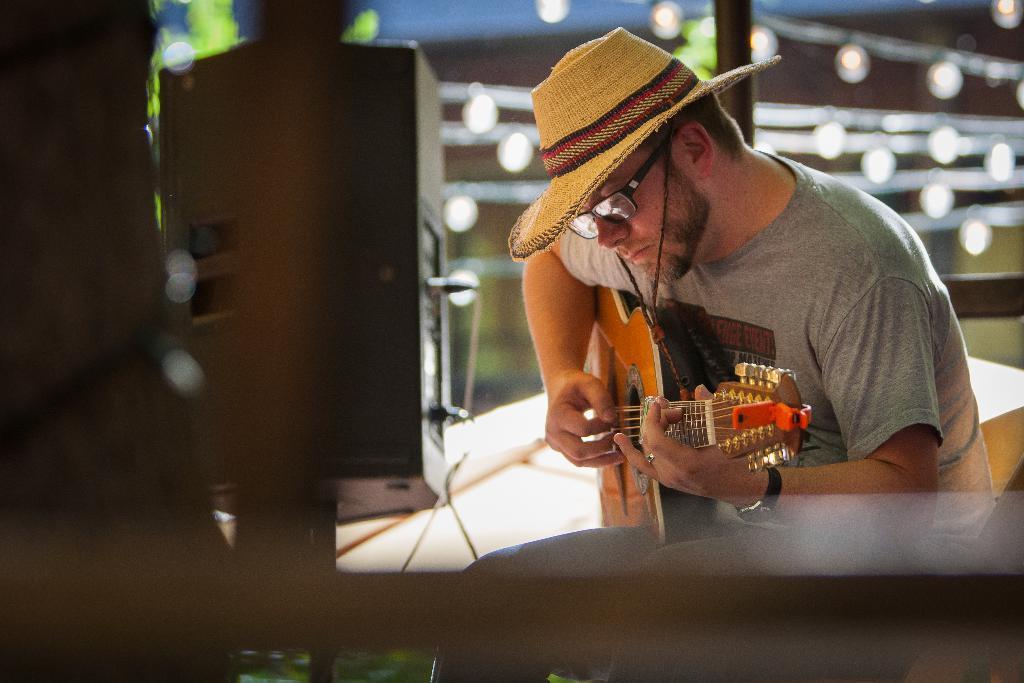In one or two sentences, can you explain what this image depicts? a person is playing guitar. he is wearing a cap. at the left there is a speaker. 